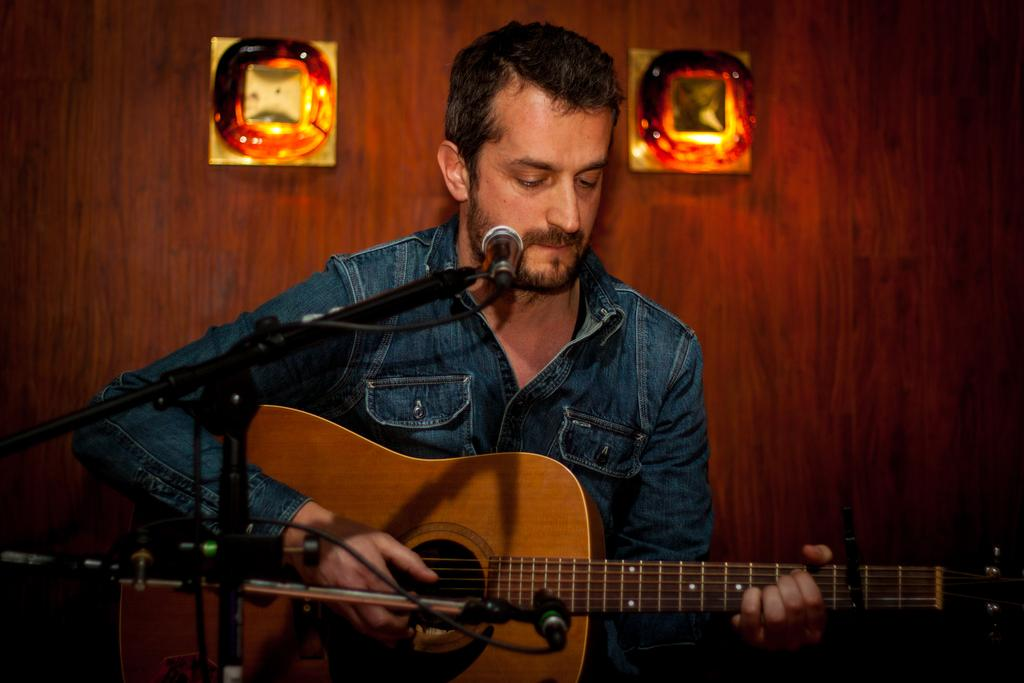What is the man in the image doing? The man is playing a guitar. What is the man wearing in the image? The man is wearing a blue shirt. What object is the man standing in front of? The man is in front of a microphone. What can be seen on the wall in the background of the image? There are photo frames on the wall in the background. What type of friction is the man experiencing while playing the guitar in the image? The image does not provide information about the friction experienced by the man while playing the guitar. What company is the man representing in the image? The image does not indicate that the man is representing any company. 